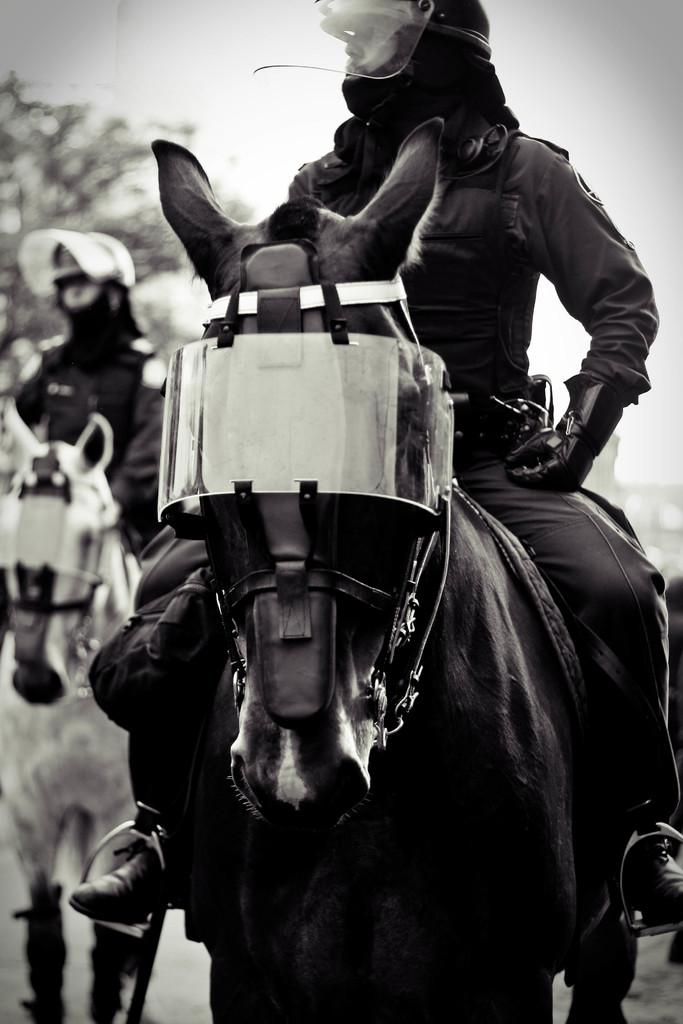What is the main subject of the image? There is a man sitting on a horse in the image. Can you describe the setting of the image? There is another man sitting on a horse in the background of the image. What type of drink is the horse holding in the image? There is no drink present in the image, as horses do not have the ability to hold or consume drinks. 